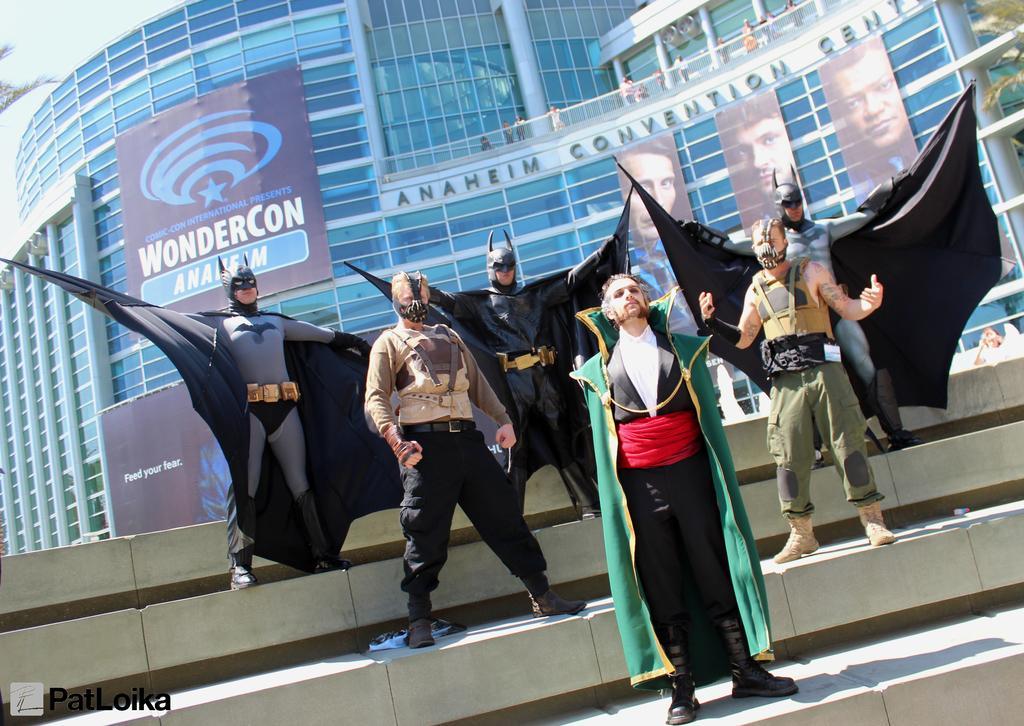Please provide a concise description of this image. In the foreground of the picture we can see people in various costumes on the staircase. In the background there buildings, people, banners, trees and sky. 